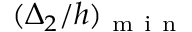Convert formula to latex. <formula><loc_0><loc_0><loc_500><loc_500>( \Delta _ { 2 } / h ) _ { m i n }</formula> 